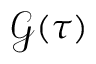<formula> <loc_0><loc_0><loc_500><loc_500>\mathcal { G } ( \tau )</formula> 